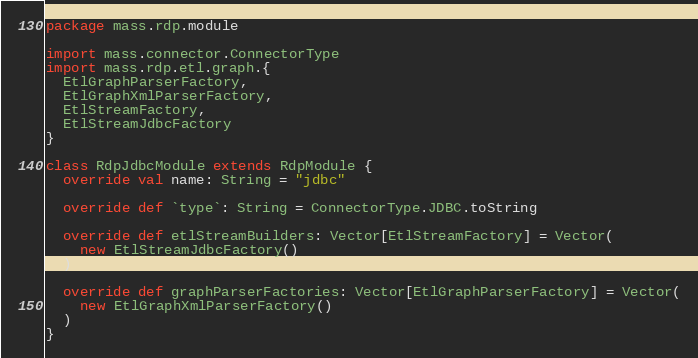Convert code to text. <code><loc_0><loc_0><loc_500><loc_500><_Scala_>package mass.rdp.module

import mass.connector.ConnectorType
import mass.rdp.etl.graph.{
  EtlGraphParserFactory,
  EtlGraphXmlParserFactory,
  EtlStreamFactory,
  EtlStreamJdbcFactory
}

class RdpJdbcModule extends RdpModule {
  override val name: String = "jdbc"

  override def `type`: String = ConnectorType.JDBC.toString

  override def etlStreamBuilders: Vector[EtlStreamFactory] = Vector(
    new EtlStreamJdbcFactory()
  )

  override def graphParserFactories: Vector[EtlGraphParserFactory] = Vector(
    new EtlGraphXmlParserFactory()
  )
}
</code> 